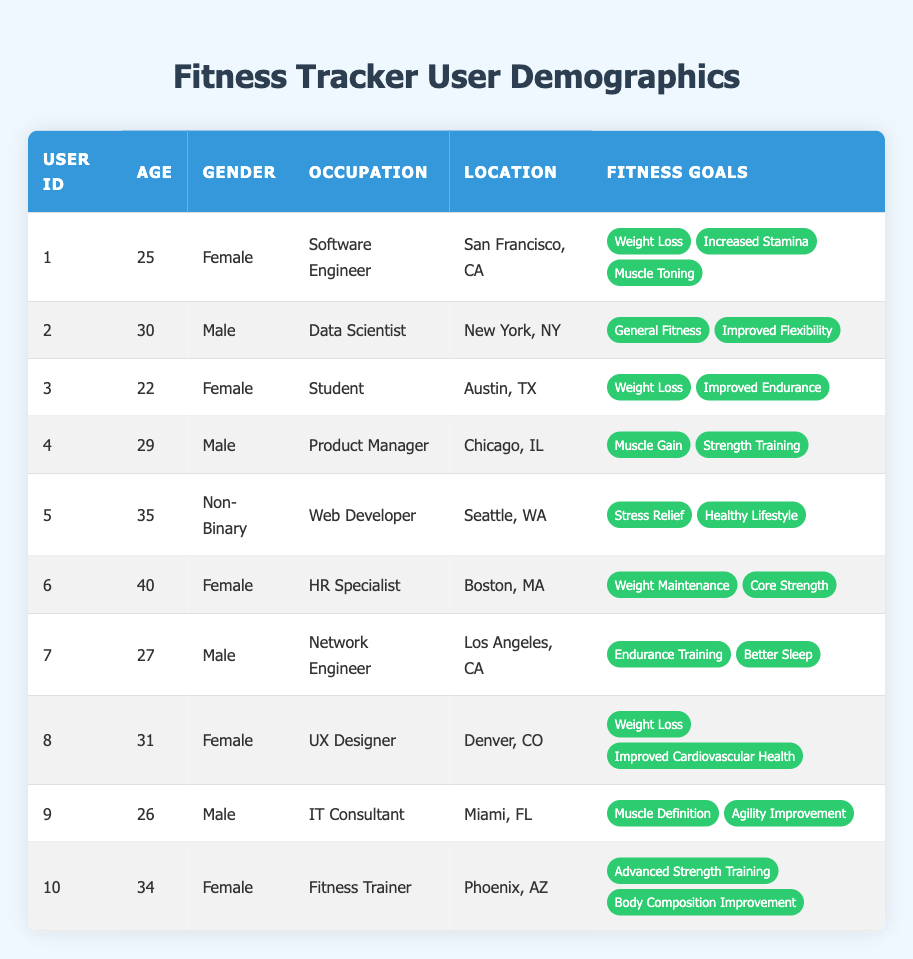What is the most common fitness goal among users? To find the most common fitness goal, we can list all fitness goals mentioned by users: Weight Loss (3 users), Increased Stamina (1), Muscle Toning (1), General Fitness (1), Improved Flexibility (1), Improved Endurance (1), Muscle Gain (1), Strength Training (1), Stress Relief (1), Healthy Lifestyle (1), Weight Maintenance (1), Core Strength (1), Endurance Training (1), Better Sleep (1), Improved Cardiovascular Health (1), Muscle Definition (1), Agility Improvement (1), Advanced Strength Training (1), Body Composition Improvement (1). The goal 'Weight Loss' is mentioned by 3 users, making it the most common.
Answer: Weight Loss How many users have a fitness goal related to weight loss? By checking the list of fitness goals for each user, we find that Users 1, 3, and 8 have 'Weight Loss' as one of their goals, totaling three users.
Answer: 3 What is the average age of the users? To calculate the average age, we add all ages (25 + 30 + 22 + 29 + 35 + 40 + 27 + 31 + 26 + 34 =  28.9) and divide by the number of users (10). The sum of the ages is 280, and the average age is 280/10 = 28.0.
Answer: 28 Are there any users from Seattle, WA, with fitness goals? Yes, User 5 is from Seattle, WA, and their fitness goals are 'Stress Relief' and 'Healthy Lifestyle'.
Answer: Yes Which gender has the highest representation in the user demographic? Counting the gender representation gives us 5 Females, 4 Males, and 1 Non-Binary user. Since Females have the highest count (5), they have the highest representation.
Answer: Female Do all users have fitness goals related to improving their physical fitness? Not all users have goals that directly relate to physical fitness; for example, User 5 has goals centered around 'Stress Relief' and 'Healthy Lifestyle', which are not specifically physical fitness goals.
Answer: No How many users are aiming for muscle-related fitness goals (Muscle Gain, Muscle Toning, Muscle Definition)? Users 1, 4, and 9 have goals specifically related to muscle (i.e., 'Muscle Toning', 'Muscle Gain', and 'Muscle Definition'). Counting these users gives us a total of 3 users.
Answer: 3 Which female user has the highest age? The female user with the highest age is User 6, who is 40 years old.
Answer: User 6 What is the ratio of male to female users in the dataset? There are 4 Male users and 5 Female users. The ratio is 4:5.
Answer: 4:5 What are the fitness goals of the user located in Los Angeles, CA? User 7, who is located in Los Angeles, CA, has fitness goals of 'Endurance Training' and 'Better Sleep'.
Answer: Endurance Training, Better Sleep 